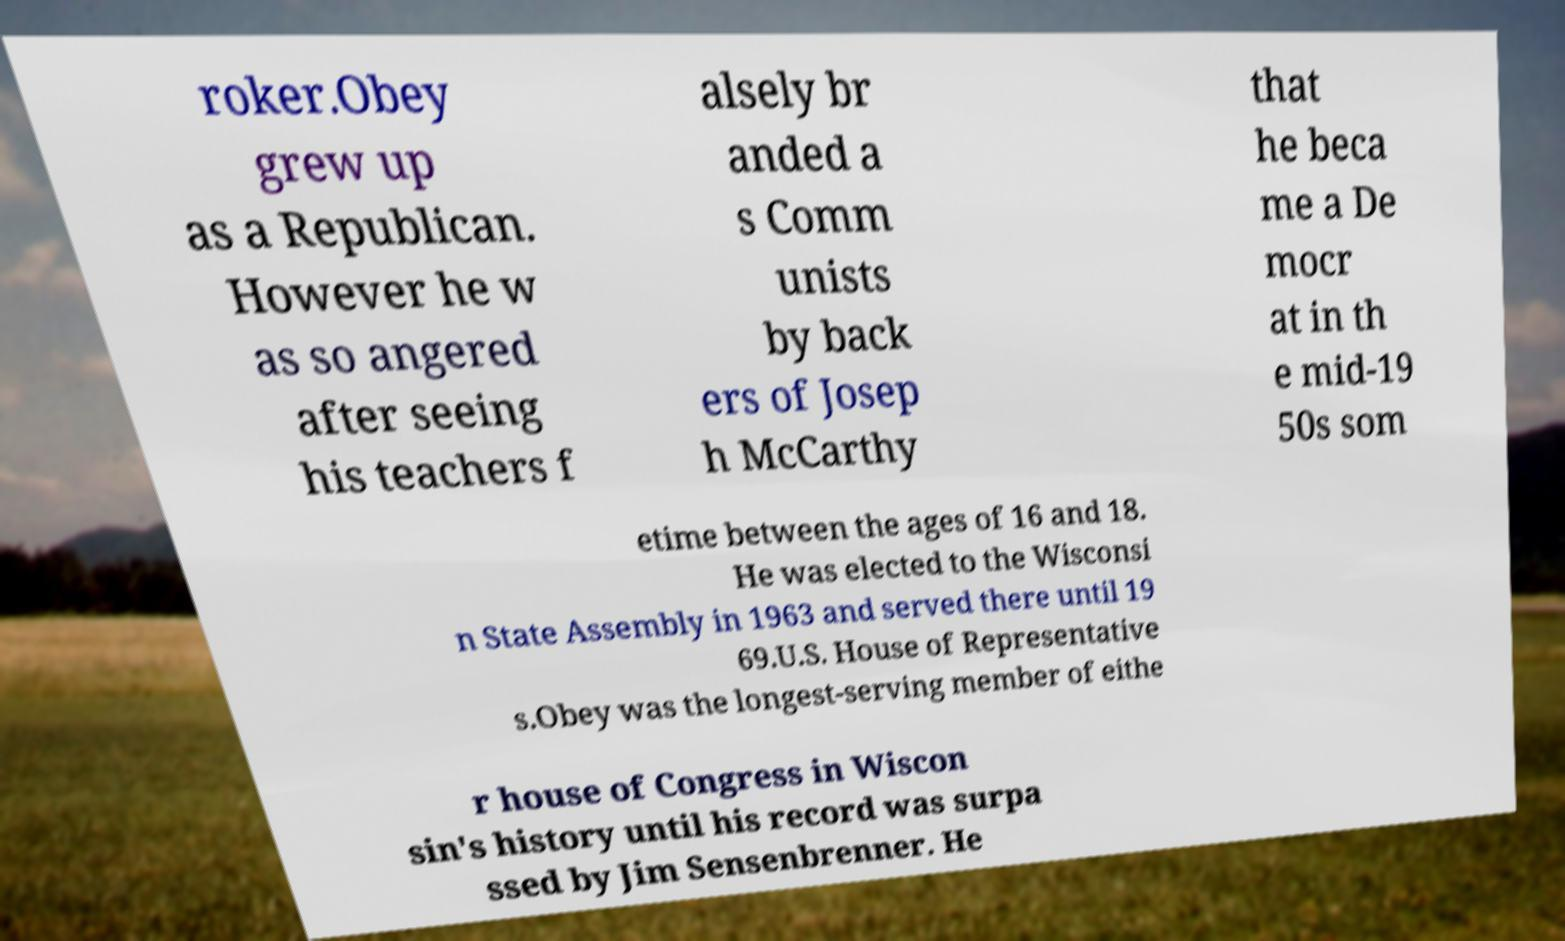There's text embedded in this image that I need extracted. Can you transcribe it verbatim? roker.Obey grew up as a Republican. However he w as so angered after seeing his teachers f alsely br anded a s Comm unists by back ers of Josep h McCarthy that he beca me a De mocr at in th e mid-19 50s som etime between the ages of 16 and 18. He was elected to the Wisconsi n State Assembly in 1963 and served there until 19 69.U.S. House of Representative s.Obey was the longest-serving member of eithe r house of Congress in Wiscon sin's history until his record was surpa ssed by Jim Sensenbrenner. He 